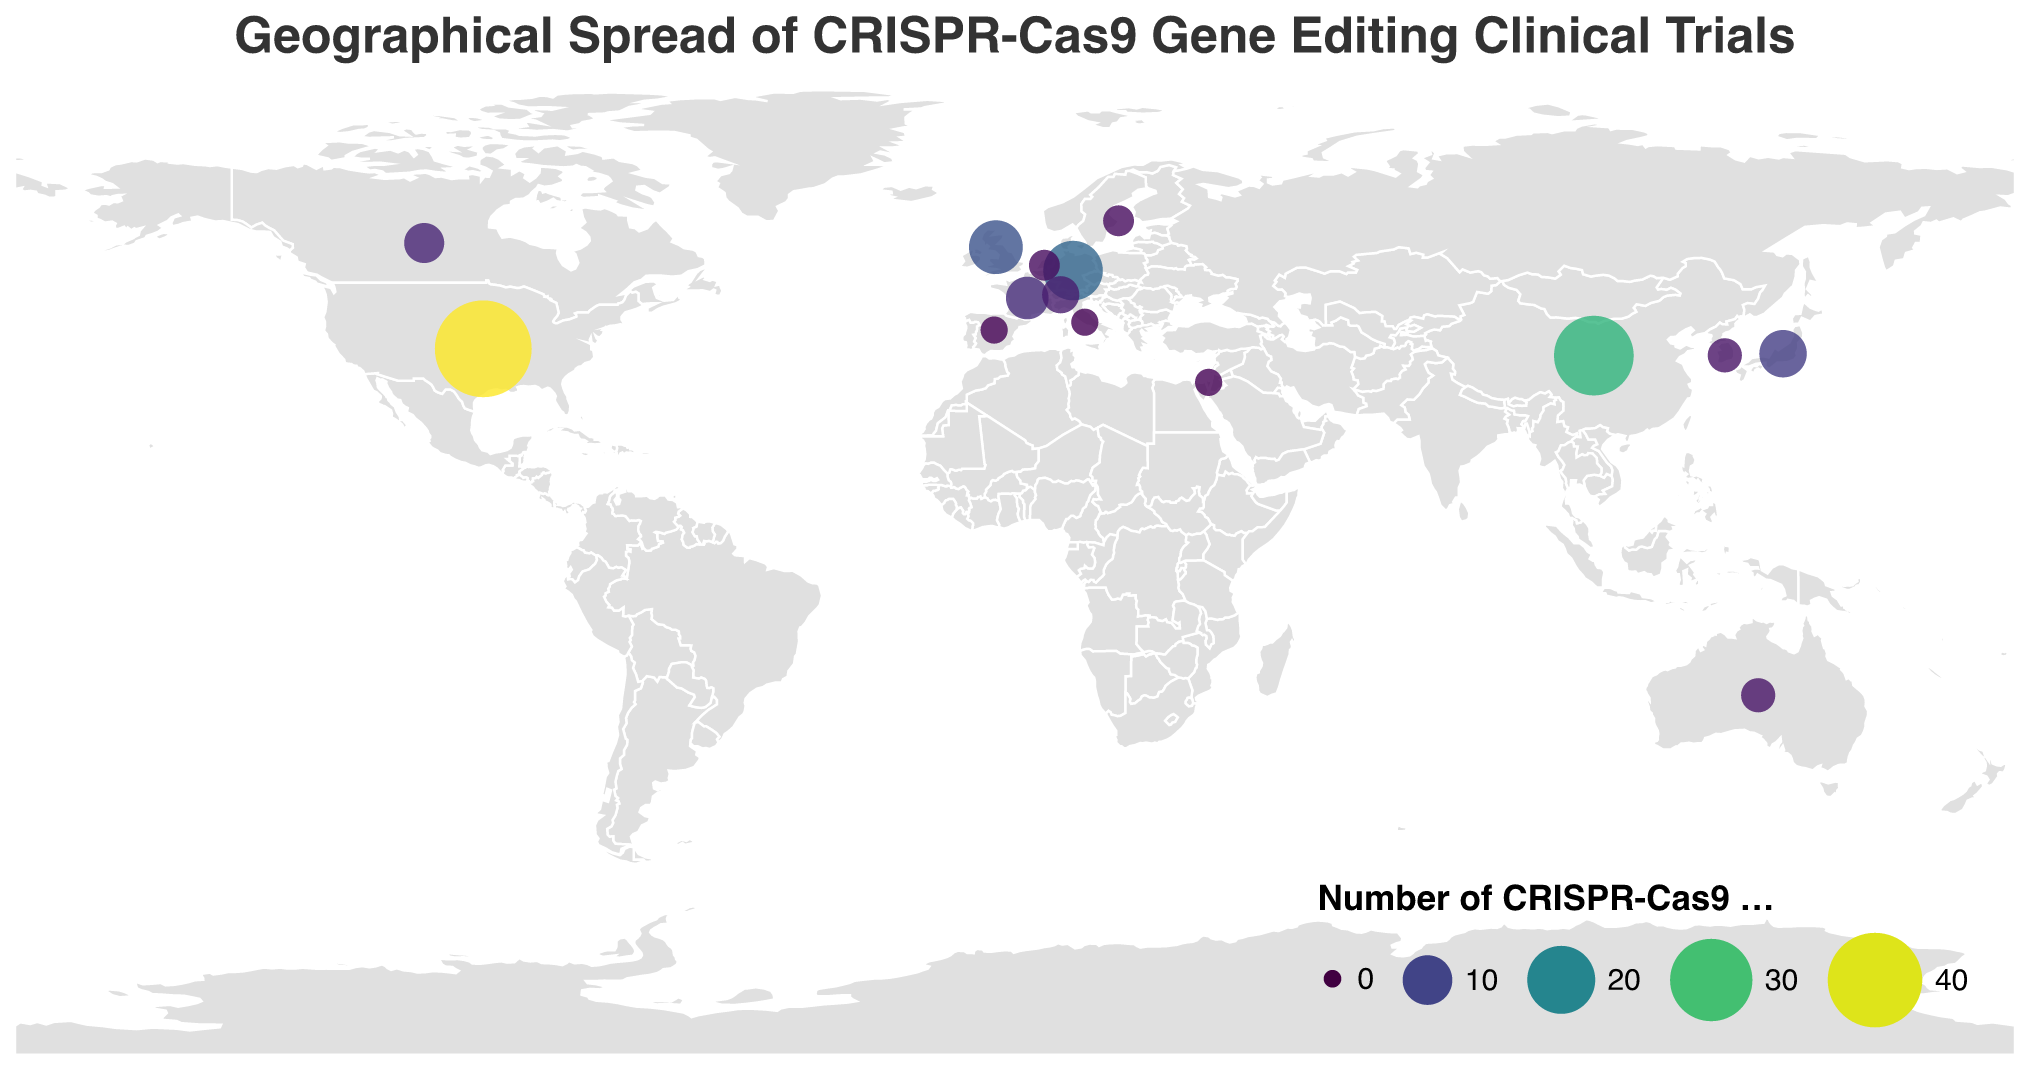What is the title of the plot? The title is located at the top of the plot and provides an overview of what the visual represents.
Answer: Geographical Spread of CRISPR-Cas9 Gene Editing Clinical Trials How many clinical trials are conducted in Germany? Look for the point labeled "Germany" on the map and refer to the tooltip or legend for the number of trials.
Answer: 15 Which country has the highest number of clinical trials? Compare the sizes of all the circles on the map, the largest circle indicates the highest number of trials.
Answer: United States What is the total number of clinical trials across all listed countries? Sum up all the provided numbers for each country: 42 (US) + 28 (China) + 15 (Germany) + 12 (UK) + 9 (Japan) + 7 (France) + 6 (Canada) + 5 (Switzerland) + 4 (Australia) + 4 (South Korea) + 3 (Netherlands) + 3 (Sweden) + 2 (Spain) + 2 (Italy) + 2 (Israel).
Answer: 144 Which country has fewer clinical trials, Australia or Canada? Compare the sizes of the circles and/or refer to the numbers in the tooltip for both countries, Australia and Canada.
Answer: Australia What are the colors representing on the map? Examine the legend or the color scheme used, which provides information on what the color gradient represents - usually a quantitative measure like the number of clinical trials.
Answer: Number of CRISPR-Cas9 Clinical Trials How many countries have exactly 3 clinical trials? Identify the circles on the map with sizes corresponding to 3 trials and count them.
Answer: 2 (Netherlands and Sweden) What is the combined number of clinical trials in France and Switzerland? Add the number of trials for both France and Switzerland: 7 (France) + 5 (Switzerland).
Answer: 12 Which two countries have the same number of clinical trials? Check the size of the circles or the numerical data and identify countries with identical counts.
Answer: Spain and Italy (both have 2) How does the number of clinical trials in the United Kingdom compare to that in Japan? Directly compare the numbers: United Kingdom has 12, and Japan has 9, see which is higher.
Answer: United Kingdom has more trials than Japan 